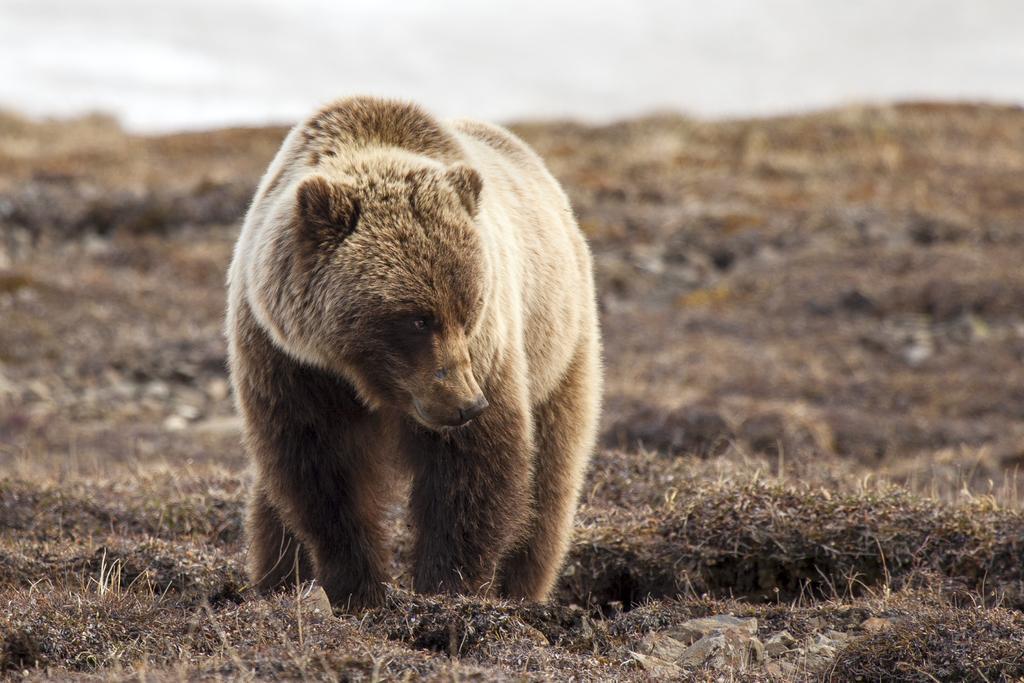Describe this image in one or two sentences. In this image we can see there is a bear standing on the ground. 